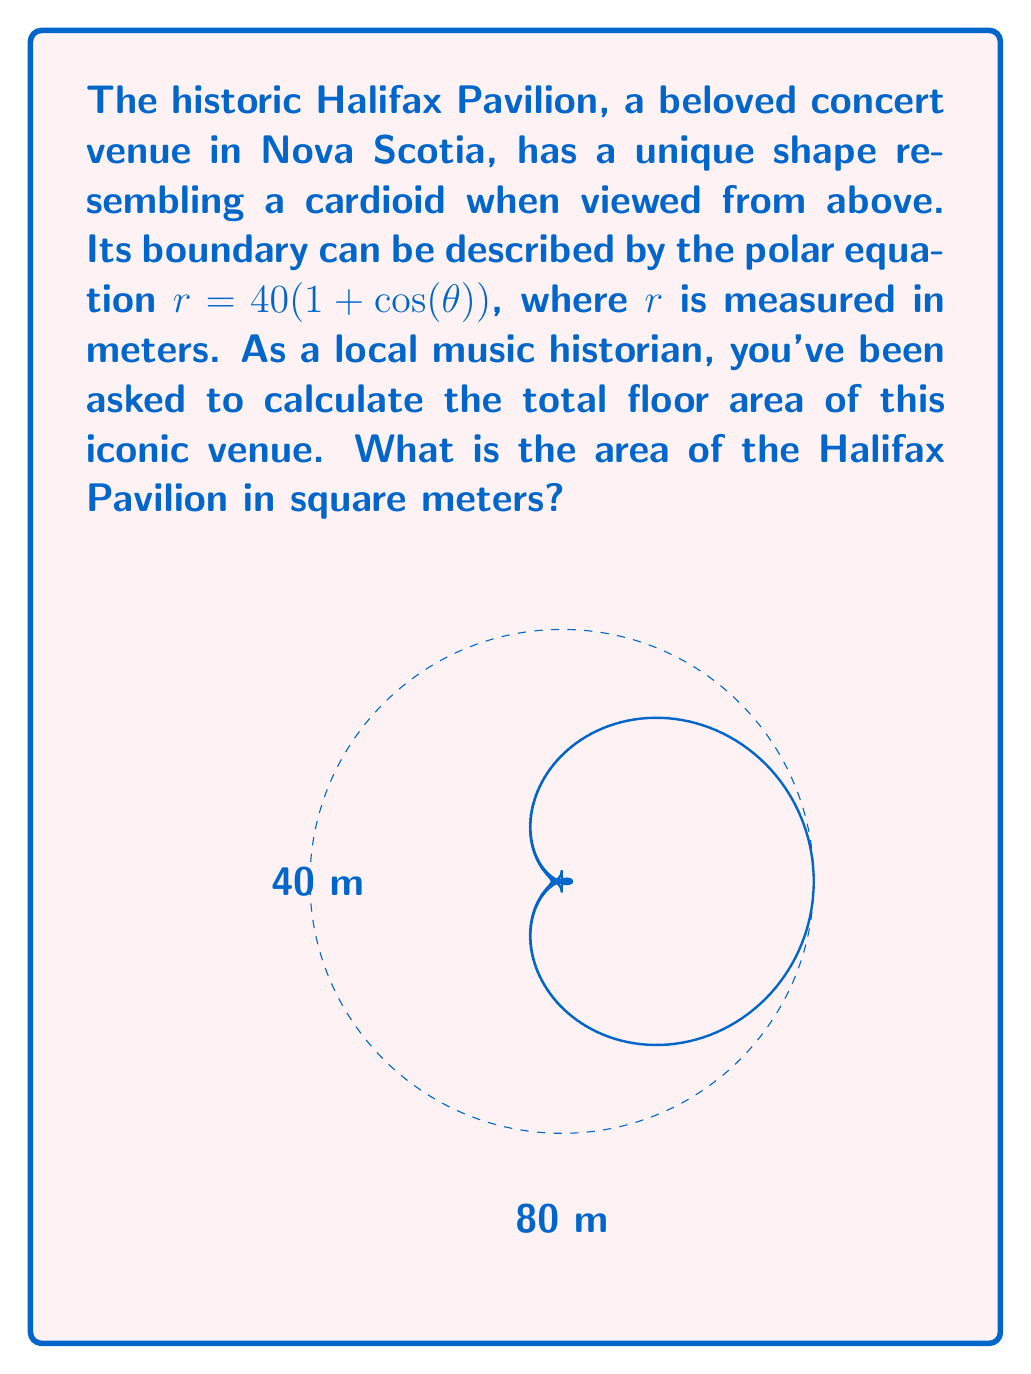Solve this math problem. To calculate the area enclosed by a polar curve, we use the formula:

$$A = \frac{1}{2} \int_0^{2\pi} r^2(\theta) d\theta$$

For the Halifax Pavilion, we have $r = 40(1 + \cos(\theta))$. Let's solve this step-by-step:

1) First, we square $r$:
   $r^2 = 1600(1 + \cos(\theta))^2 = 1600(1 + 2\cos(\theta) + \cos^2(\theta))$

2) Now, we set up our integral:
   $$A = \frac{1}{2} \int_0^{2\pi} 1600(1 + 2\cos(\theta) + \cos^2(\theta)) d\theta$$

3) Simplify the constant:
   $$A = 800 \int_0^{2\pi} (1 + 2\cos(\theta) + \cos^2(\theta)) d\theta$$

4) We can split this into three integrals:
   $$A = 800 \left[\int_0^{2\pi} 1 d\theta + 2\int_0^{2\pi} \cos(\theta) d\theta + \int_0^{2\pi} \cos^2(\theta) d\theta\right]$$

5) Evaluate each integral:
   - $\int_0^{2\pi} 1 d\theta = 2\pi$
   - $\int_0^{2\pi} \cos(\theta) d\theta = 0$
   - $\int_0^{2\pi} \cos^2(\theta) d\theta = \pi$

6) Substitute these results:
   $$A = 800 [2\pi + 0 + \pi] = 800 \cdot 3\pi = 2400\pi$$

Therefore, the area of the Halifax Pavilion is $2400\pi$ square meters.
Answer: $2400\pi$ m² 